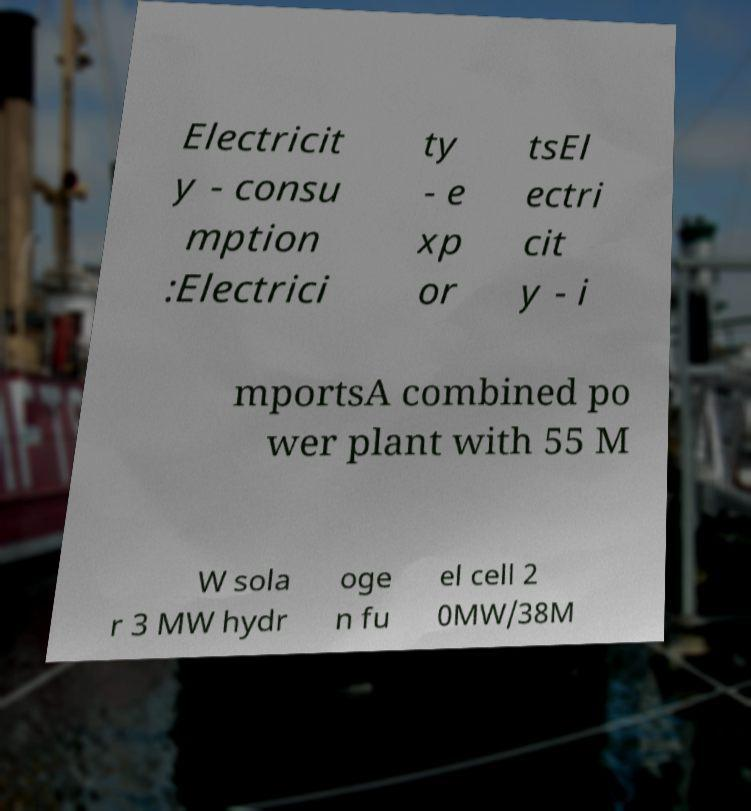There's text embedded in this image that I need extracted. Can you transcribe it verbatim? Electricit y - consu mption :Electrici ty - e xp or tsEl ectri cit y - i mportsA combined po wer plant with 55 M W sola r 3 MW hydr oge n fu el cell 2 0MW/38M 